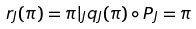Convert formula to latex. <formula><loc_0><loc_0><loc_500><loc_500>r _ { J } ( \pi ) = \pi | _ { J } q _ { J } ( \pi ) \circ P _ { J } = \pi</formula> 